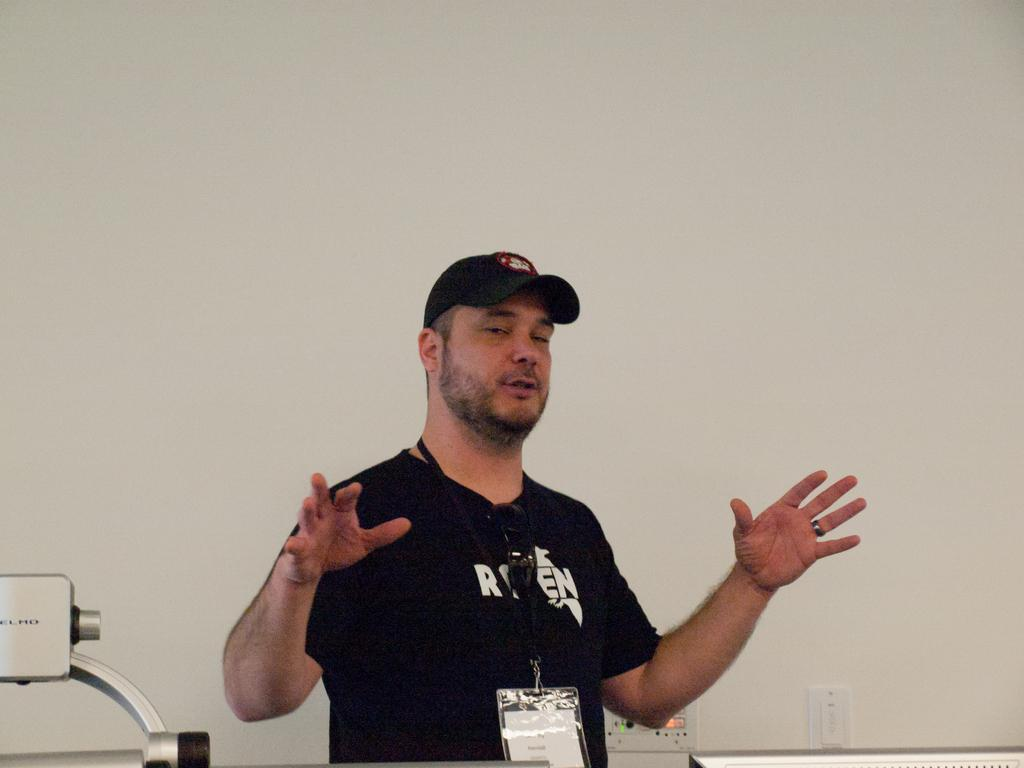What is the main subject of the image? There is a person in the image. What is the person wearing on their upper body? The person is wearing a black t-shirt. What type of headwear is the person wearing? The person is wearing a cap. Does the person have any form of identification visible? Yes, the person has an id card. What can be seen behind the person in the image? There is a wall behind the person. How does the person roll in the image? The person is not rolling in the image; they are standing still. What type of material is the person trying to cover in the image? There is no indication in the image that the person is trying to cover anything. 